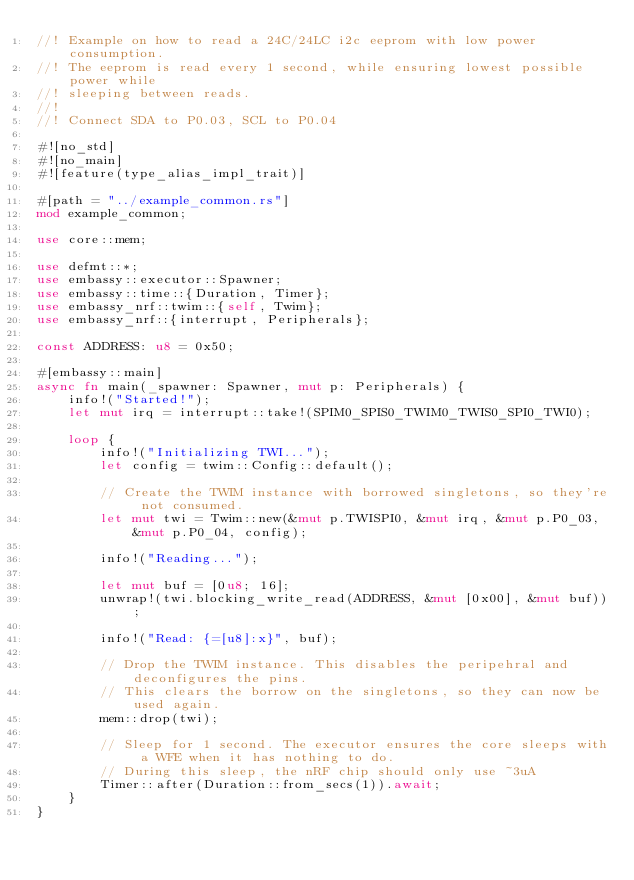Convert code to text. <code><loc_0><loc_0><loc_500><loc_500><_Rust_>//! Example on how to read a 24C/24LC i2c eeprom with low power consumption.
//! The eeprom is read every 1 second, while ensuring lowest possible power while
//! sleeping between reads.
//!
//! Connect SDA to P0.03, SCL to P0.04

#![no_std]
#![no_main]
#![feature(type_alias_impl_trait)]

#[path = "../example_common.rs"]
mod example_common;

use core::mem;

use defmt::*;
use embassy::executor::Spawner;
use embassy::time::{Duration, Timer};
use embassy_nrf::twim::{self, Twim};
use embassy_nrf::{interrupt, Peripherals};

const ADDRESS: u8 = 0x50;

#[embassy::main]
async fn main(_spawner: Spawner, mut p: Peripherals) {
    info!("Started!");
    let mut irq = interrupt::take!(SPIM0_SPIS0_TWIM0_TWIS0_SPI0_TWI0);

    loop {
        info!("Initializing TWI...");
        let config = twim::Config::default();

        // Create the TWIM instance with borrowed singletons, so they're not consumed.
        let mut twi = Twim::new(&mut p.TWISPI0, &mut irq, &mut p.P0_03, &mut p.P0_04, config);

        info!("Reading...");

        let mut buf = [0u8; 16];
        unwrap!(twi.blocking_write_read(ADDRESS, &mut [0x00], &mut buf));

        info!("Read: {=[u8]:x}", buf);

        // Drop the TWIM instance. This disables the peripehral and deconfigures the pins.
        // This clears the borrow on the singletons, so they can now be used again.
        mem::drop(twi);

        // Sleep for 1 second. The executor ensures the core sleeps with a WFE when it has nothing to do.
        // During this sleep, the nRF chip should only use ~3uA
        Timer::after(Duration::from_secs(1)).await;
    }
}
</code> 